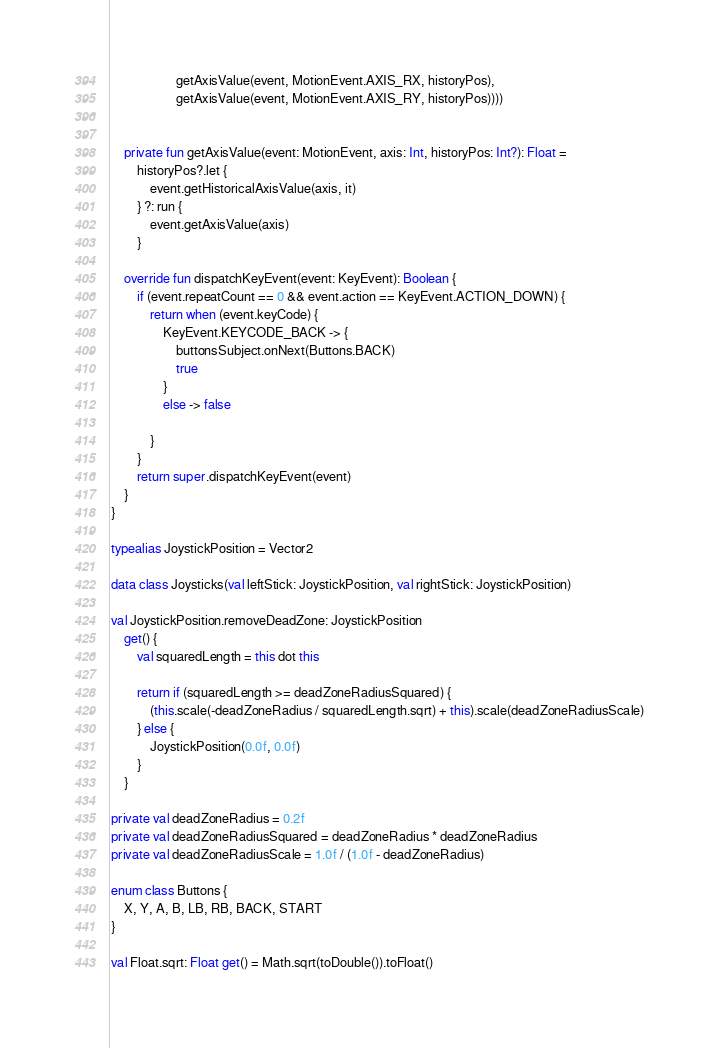Convert code to text. <code><loc_0><loc_0><loc_500><loc_500><_Kotlin_>                    getAxisValue(event, MotionEvent.AXIS_RX, historyPos),
                    getAxisValue(event, MotionEvent.AXIS_RY, historyPos))))


    private fun getAxisValue(event: MotionEvent, axis: Int, historyPos: Int?): Float =
        historyPos?.let {
            event.getHistoricalAxisValue(axis, it)
        } ?: run {
            event.getAxisValue(axis)
        }

    override fun dispatchKeyEvent(event: KeyEvent): Boolean {
        if (event.repeatCount == 0 && event.action == KeyEvent.ACTION_DOWN) {
            return when (event.keyCode) {
                KeyEvent.KEYCODE_BACK -> {
                    buttonsSubject.onNext(Buttons.BACK)
                    true
                }
                else -> false

            }
        }
        return super.dispatchKeyEvent(event)
    }
}

typealias JoystickPosition = Vector2

data class Joysticks(val leftStick: JoystickPosition, val rightStick: JoystickPosition)

val JoystickPosition.removeDeadZone: JoystickPosition
    get() {
        val squaredLength = this dot this

        return if (squaredLength >= deadZoneRadiusSquared) {
            (this.scale(-deadZoneRadius / squaredLength.sqrt) + this).scale(deadZoneRadiusScale)
        } else {
            JoystickPosition(0.0f, 0.0f)
        }
    }

private val deadZoneRadius = 0.2f
private val deadZoneRadiusSquared = deadZoneRadius * deadZoneRadius
private val deadZoneRadiusScale = 1.0f / (1.0f - deadZoneRadius)

enum class Buttons {
    X, Y, A, B, LB, RB, BACK, START
}

val Float.sqrt: Float get() = Math.sqrt(toDouble()).toFloat()
</code> 